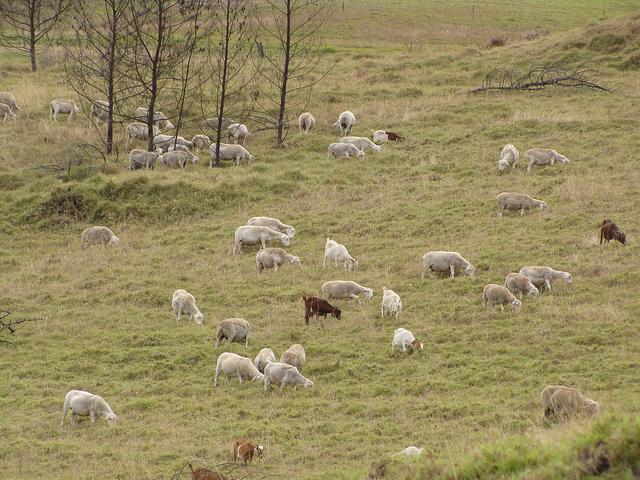Are there any giraffes in this photo?
Concise answer only. No. Are all the animals the same color as each other?
Keep it brief. No. What are these animals doing?
Quick response, please. Grazing. Are there various animals?
Answer briefly. Yes. 